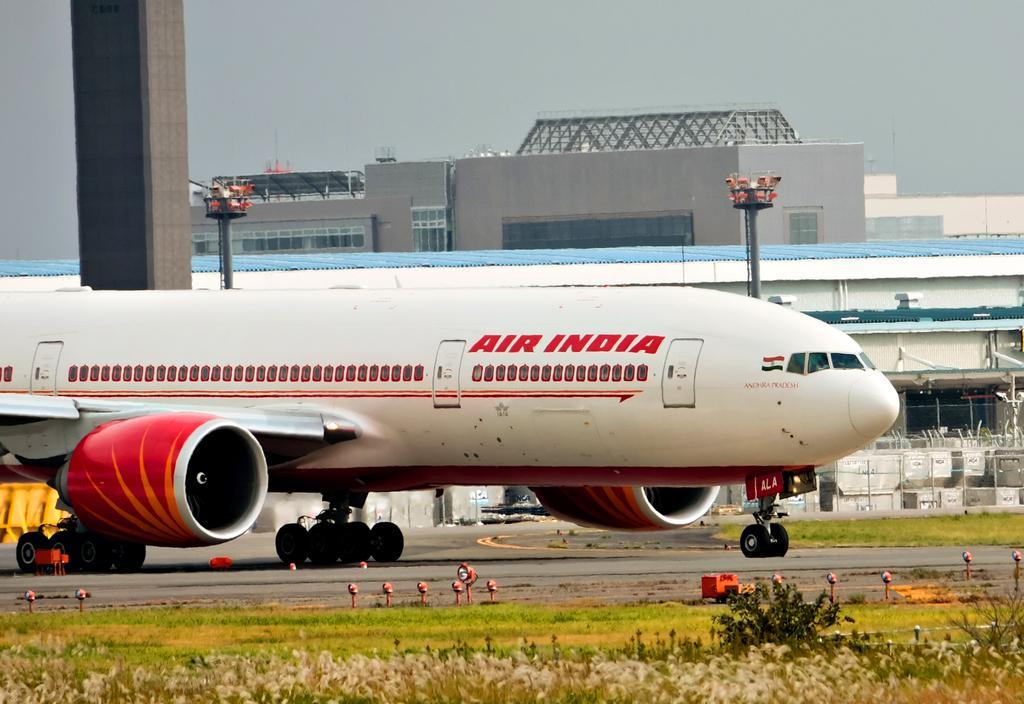Please provide a concise description of this image. In this picture we can see an airplane in the middle, at the bottom there is some grass and some plants, on the left side there is a pillar, in the background there are poles and a building, there is the sky at the top of the picture. 